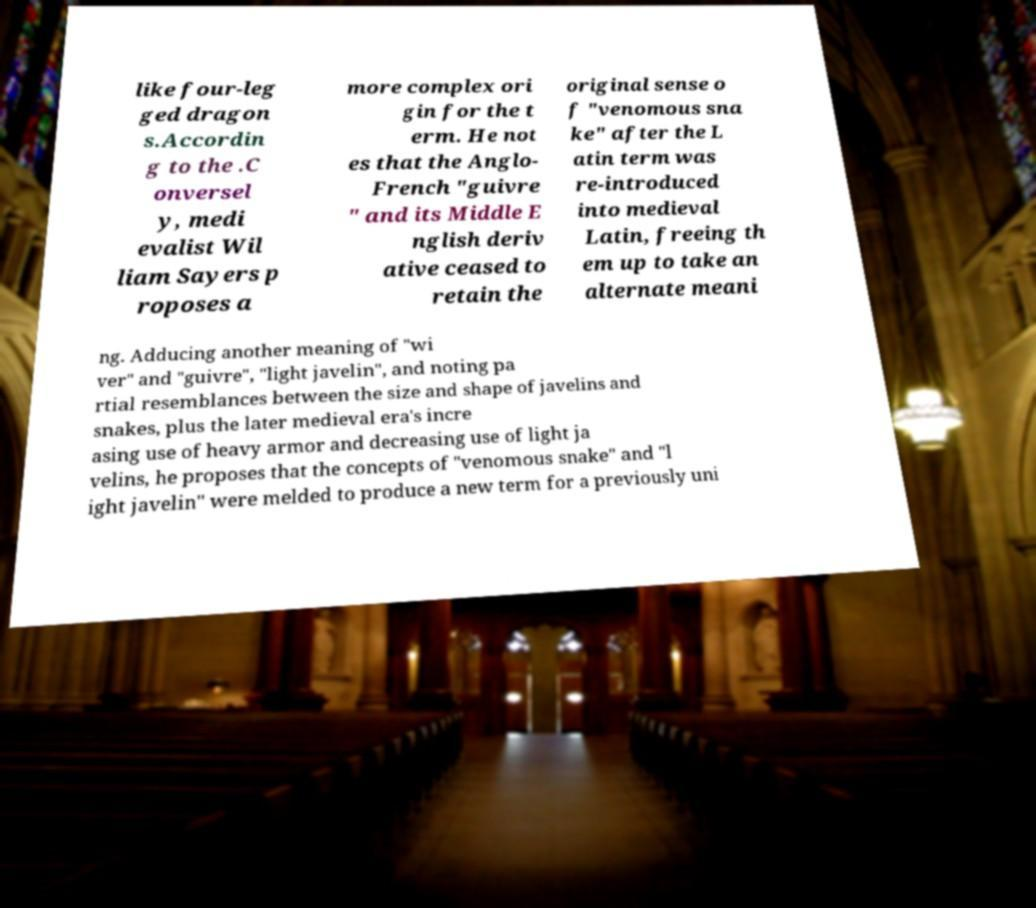For documentation purposes, I need the text within this image transcribed. Could you provide that? like four-leg ged dragon s.Accordin g to the .C onversel y, medi evalist Wil liam Sayers p roposes a more complex ori gin for the t erm. He not es that the Anglo- French "guivre " and its Middle E nglish deriv ative ceased to retain the original sense o f "venomous sna ke" after the L atin term was re-introduced into medieval Latin, freeing th em up to take an alternate meani ng. Adducing another meaning of "wi ver" and "guivre", "light javelin", and noting pa rtial resemblances between the size and shape of javelins and snakes, plus the later medieval era's incre asing use of heavy armor and decreasing use of light ja velins, he proposes that the concepts of "venomous snake" and "l ight javelin" were melded to produce a new term for a previously uni 